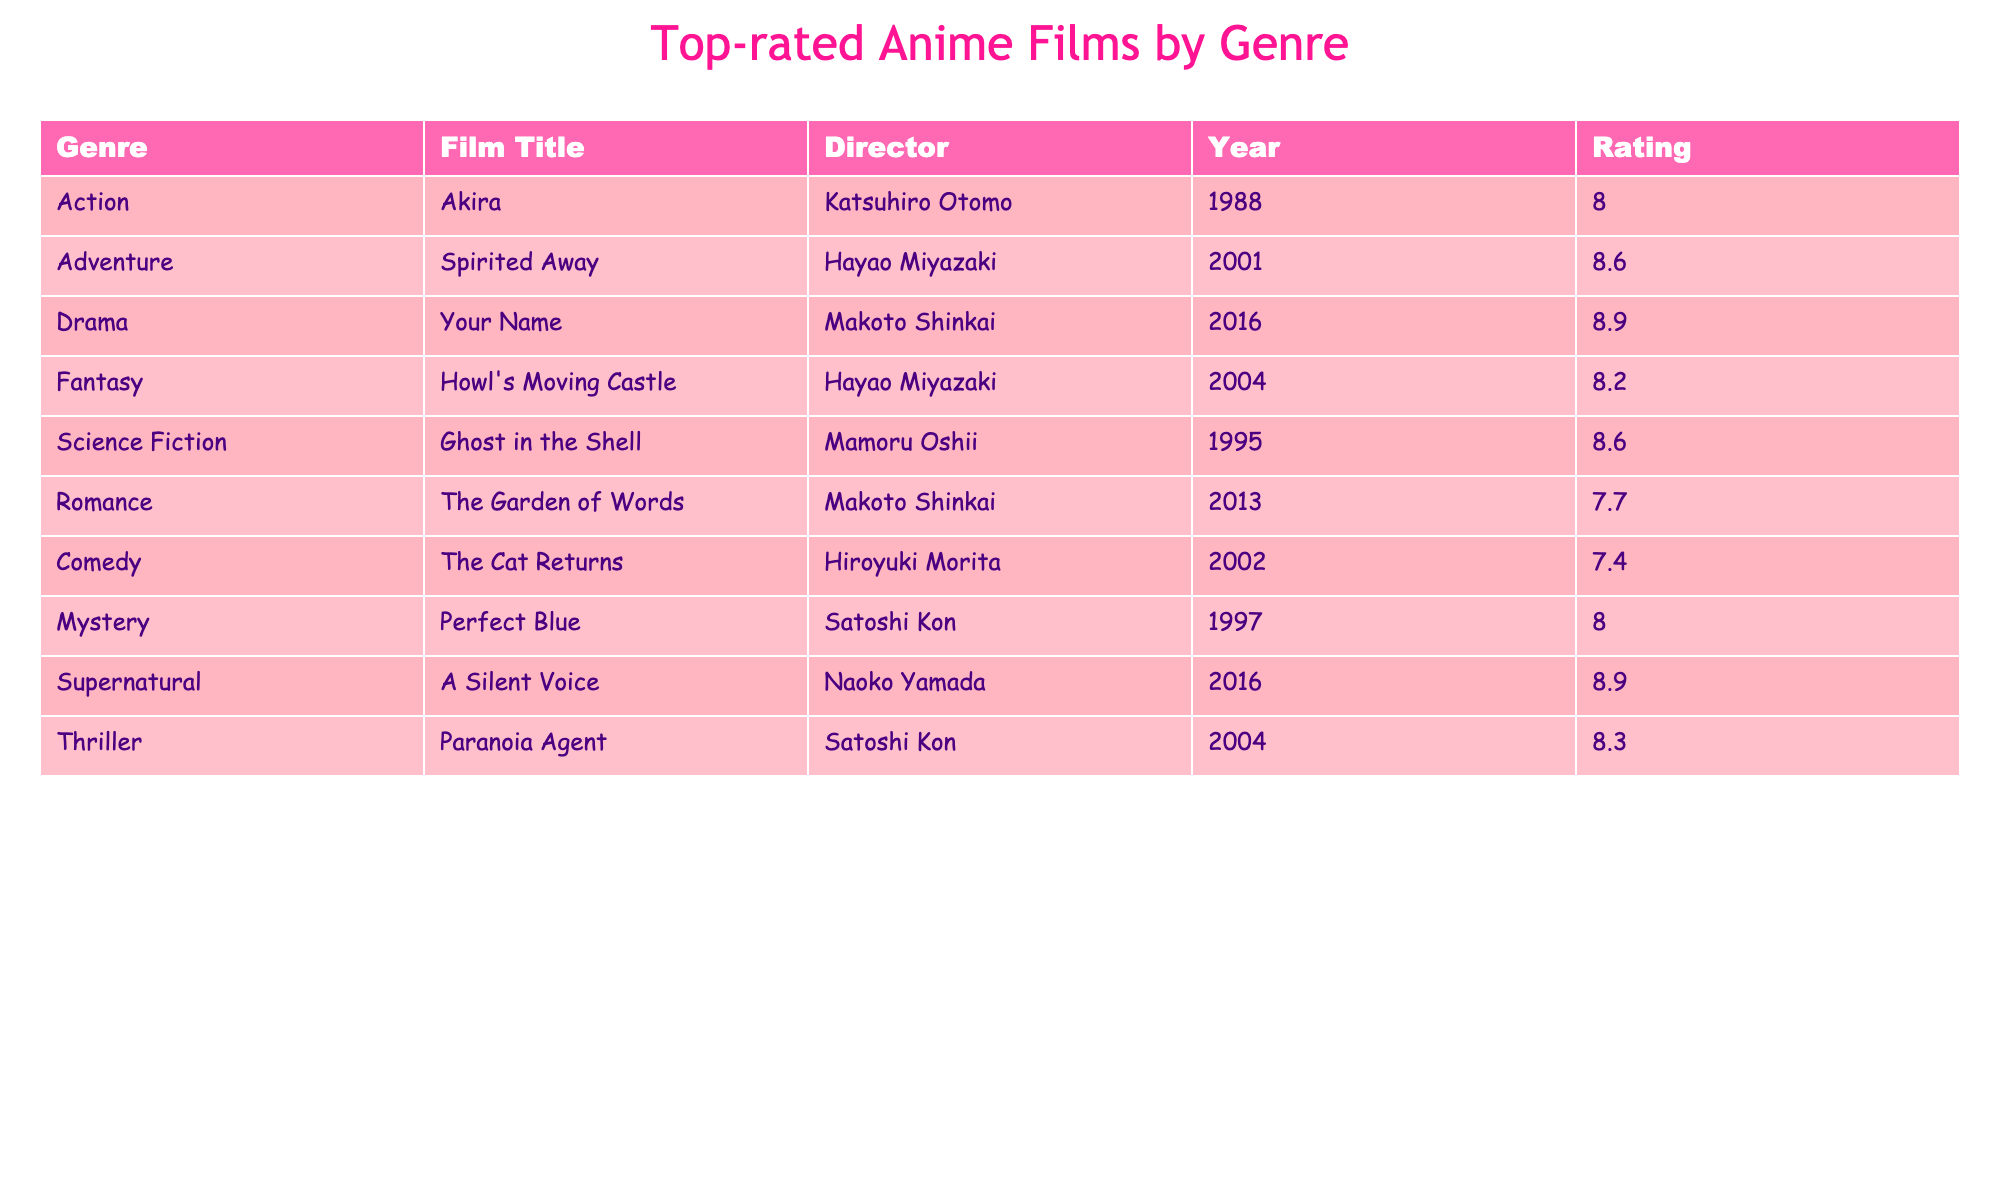What is the highest-rated anime film in the table? The table lists each film along with its rating. By looking through the ratings, "Your Name" has the highest rating of 8.9.
Answer: 8.9 Which film was directed by Hayao Miyazaki? The table features multiple films and their directors. Scanning the table reveals that "Spirited Away" and "Howl's Moving Castle" were both directed by Hayao Miyazaki.
Answer: Spirited Away, Howl's Moving Castle Is there an anime film rated 7.0 or lower? By reviewing the ratings, the lowest rating in the table is 7.4 for "The Cat Returns." There are no films rated 7.0 or lower.
Answer: No What is the average rating of the films directed by Makoto Shinkai? Two films directed by Makoto Shinkai are "Your Name" and "The Garden of Words." Their ratings are 8.9 and 7.7 respectively. To find the average, sum them up (8.9 + 7.7 = 16.6) and divide by the number of films (16.6 / 2 = 8.3).
Answer: 8.3 Which genre has the film with the oldest release year? The table shows the release years for each film. The oldest film is "Akira," released in 1988. The genre for "Akira" is Action.
Answer: Action How many genres have films rated 8.0 or higher? By scanning the ratings, the films with ratings 8.0 or higher are: "Akira" (Action), "Spirited Away" (Adventure), "Your Name" (Drama), "Howl's Moving Castle" (Fantasy), "Ghost in the Shell" (Science Fiction), "A Silent Voice" (Supernatural), “Perfect Blue” (Mystery), and “Paranoia Agent” (Thriller). This totals 8 different genres.
Answer: 8 Is "The Cat Returns" the only film directed by Hiroyuki Morita? The table lists "The Cat Returns" as directed by Hiroyuki Morita, and does not indicate any other film directed by him. Therefore, he is only credited with this one film in the table.
Answer: Yes Which film has the longest title? By comparing the number of characters in each film title, "Howl's Moving Castle" has the longest title with 21 characters.
Answer: Howl's Moving Castle 